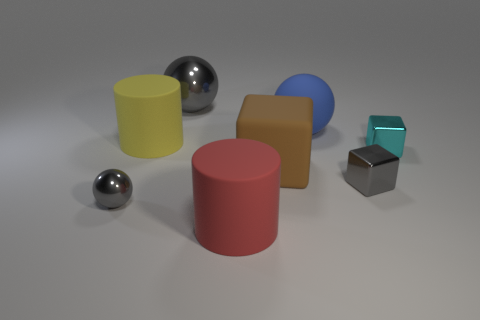Add 1 big yellow objects. How many objects exist? 9 Subtract all spheres. How many objects are left? 5 Add 6 rubber objects. How many rubber objects exist? 10 Subtract 0 cyan balls. How many objects are left? 8 Subtract all cyan metal cylinders. Subtract all tiny metallic blocks. How many objects are left? 6 Add 3 brown rubber cubes. How many brown rubber cubes are left? 4 